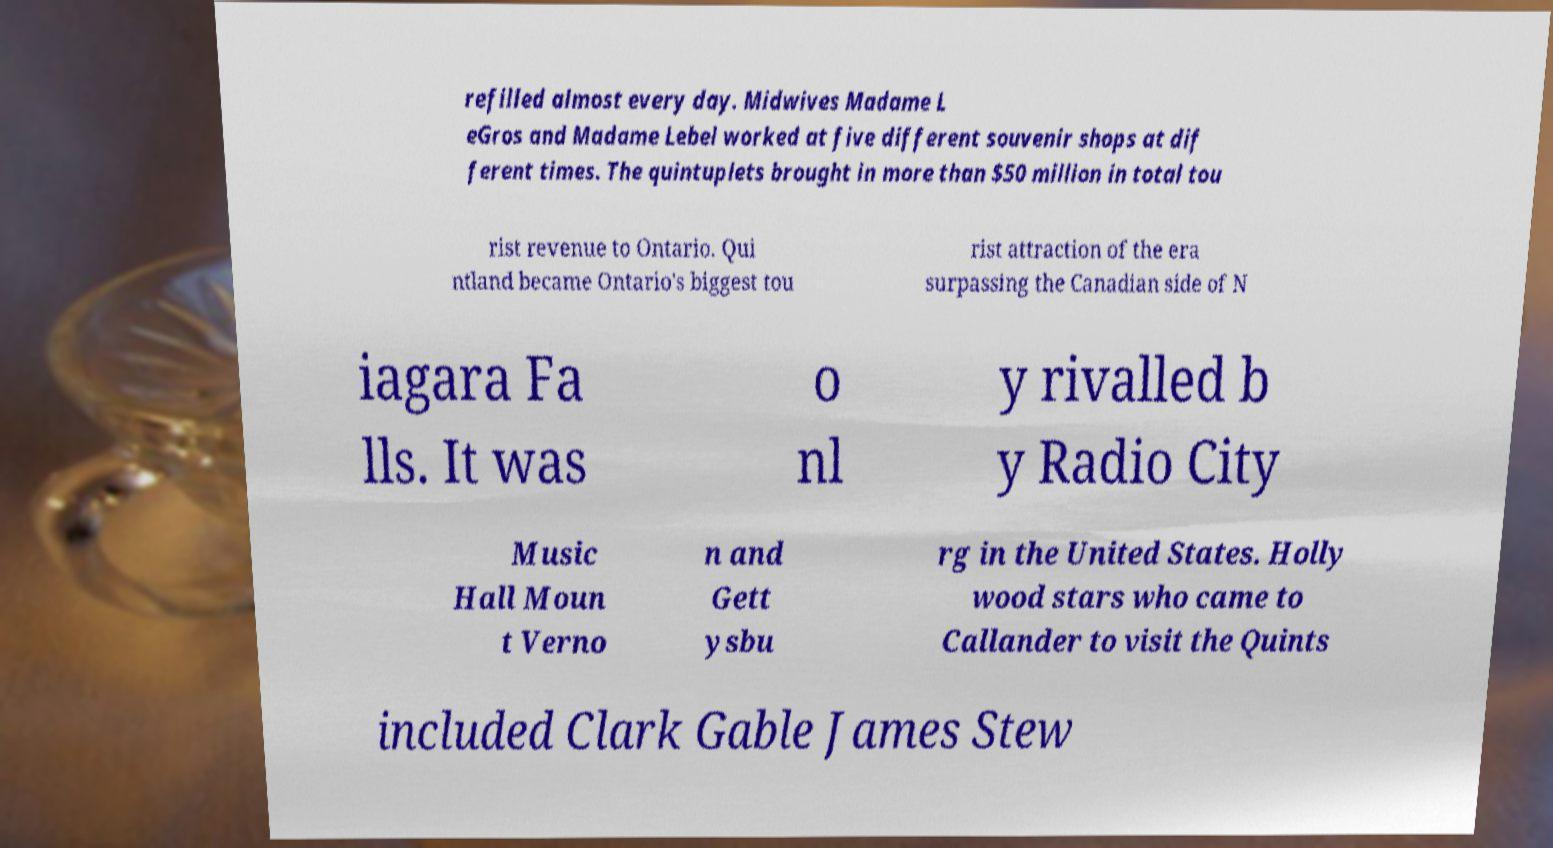Can you read and provide the text displayed in the image?This photo seems to have some interesting text. Can you extract and type it out for me? refilled almost every day. Midwives Madame L eGros and Madame Lebel worked at five different souvenir shops at dif ferent times. The quintuplets brought in more than $50 million in total tou rist revenue to Ontario. Qui ntland became Ontario's biggest tou rist attraction of the era surpassing the Canadian side of N iagara Fa lls. It was o nl y rivalled b y Radio City Music Hall Moun t Verno n and Gett ysbu rg in the United States. Holly wood stars who came to Callander to visit the Quints included Clark Gable James Stew 